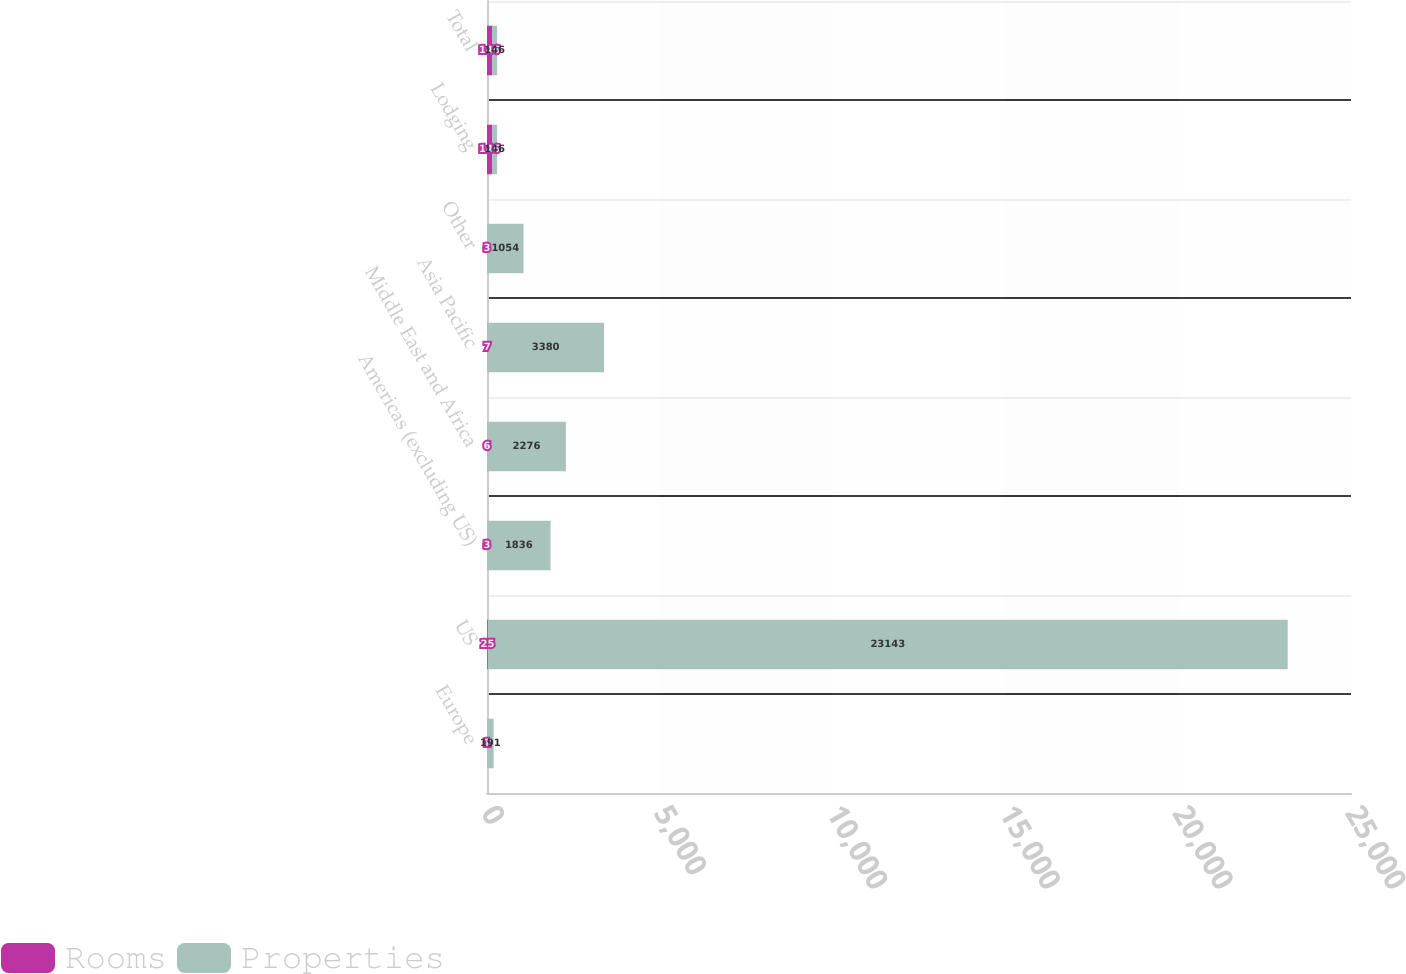Convert chart. <chart><loc_0><loc_0><loc_500><loc_500><stacked_bar_chart><ecel><fcel>Europe<fcel>US<fcel>Americas (excluding US)<fcel>Middle East and Africa<fcel>Asia Pacific<fcel>Other<fcel>Lodging<fcel>Total<nl><fcel>Rooms<fcel>1<fcel>25<fcel>3<fcel>6<fcel>7<fcel>3<fcel>146<fcel>146<nl><fcel>Properties<fcel>191<fcel>23143<fcel>1836<fcel>2276<fcel>3380<fcel>1054<fcel>146<fcel>146<nl></chart> 